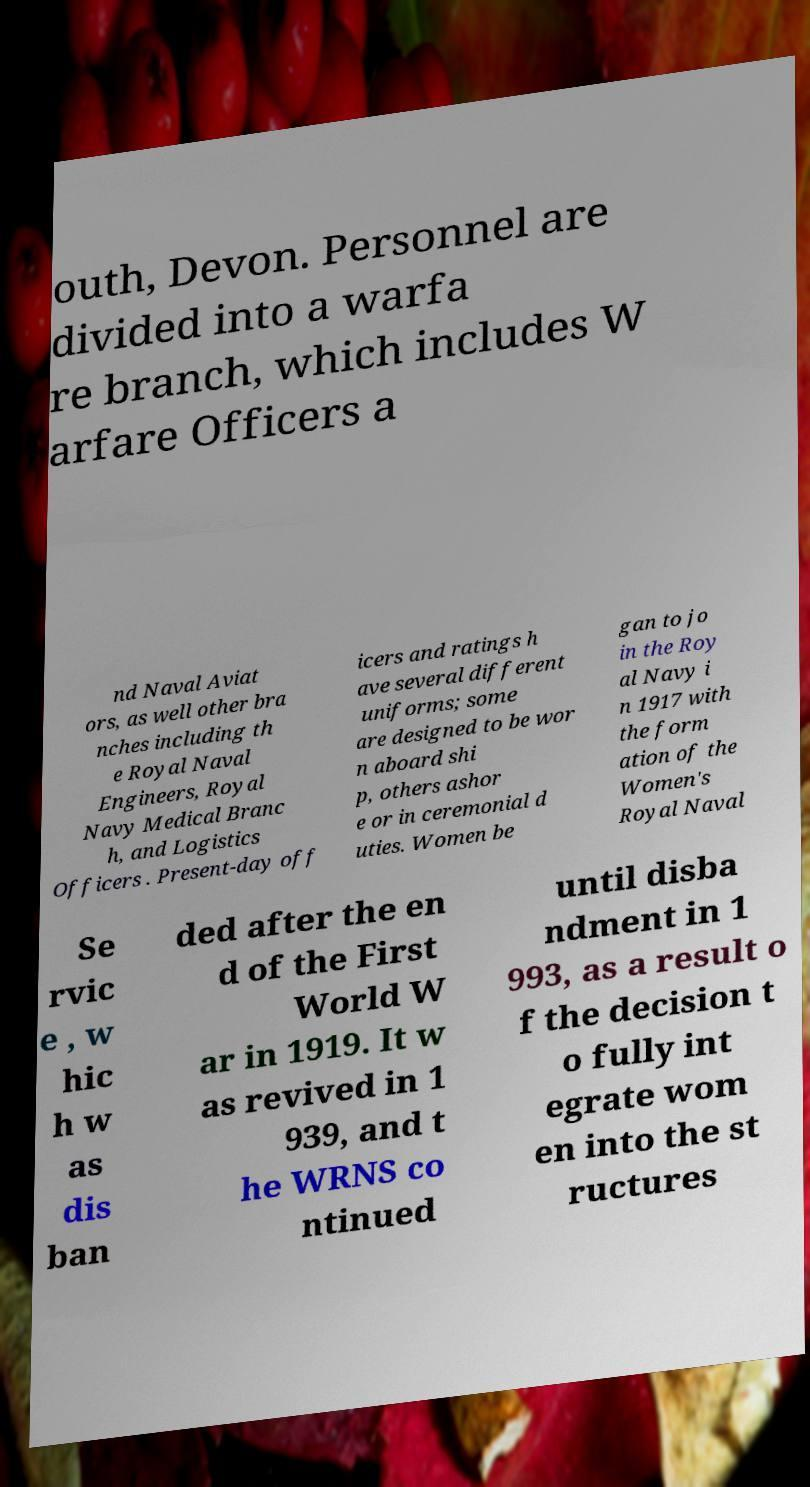Could you assist in decoding the text presented in this image and type it out clearly? outh, Devon. Personnel are divided into a warfa re branch, which includes W arfare Officers a nd Naval Aviat ors, as well other bra nches including th e Royal Naval Engineers, Royal Navy Medical Branc h, and Logistics Officers . Present-day off icers and ratings h ave several different uniforms; some are designed to be wor n aboard shi p, others ashor e or in ceremonial d uties. Women be gan to jo in the Roy al Navy i n 1917 with the form ation of the Women's Royal Naval Se rvic e , w hic h w as dis ban ded after the en d of the First World W ar in 1919. It w as revived in 1 939, and t he WRNS co ntinued until disba ndment in 1 993, as a result o f the decision t o fully int egrate wom en into the st ructures 